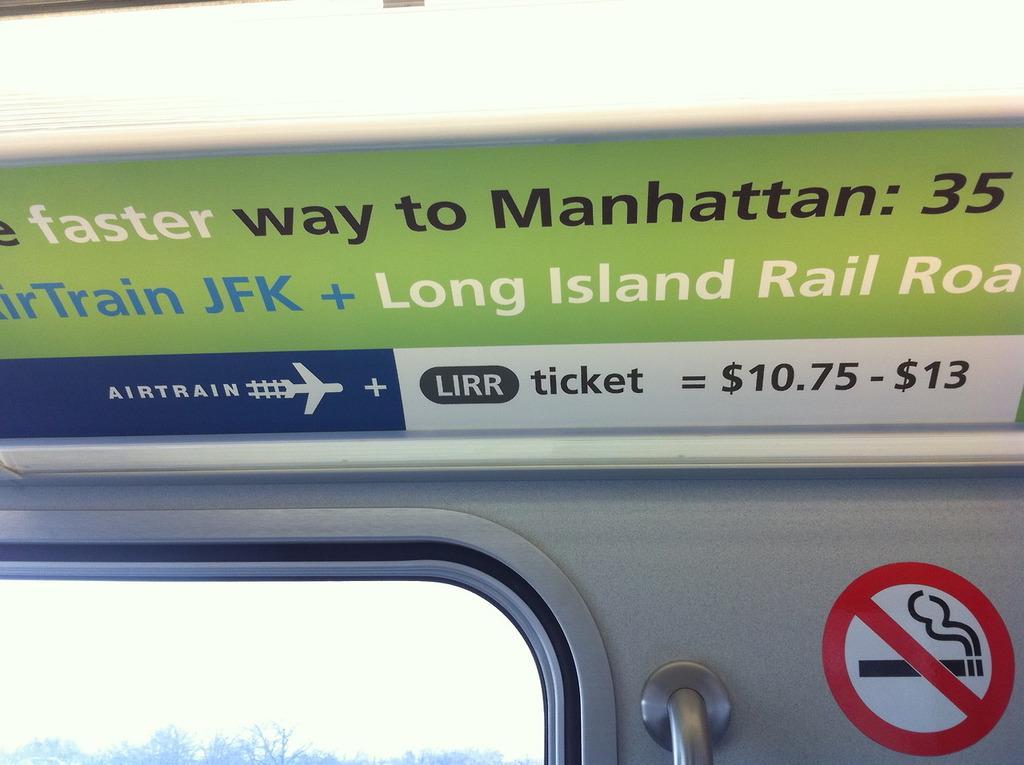How would you summarize this image in a sentence or two? In this image I can see a board on the top side and on it I can see something is written. On the right side of this image I can see a no smoking sign board and on the left side I can see window. Through the window I can see number of trees and on the bottom right side I can see an iron pole. 